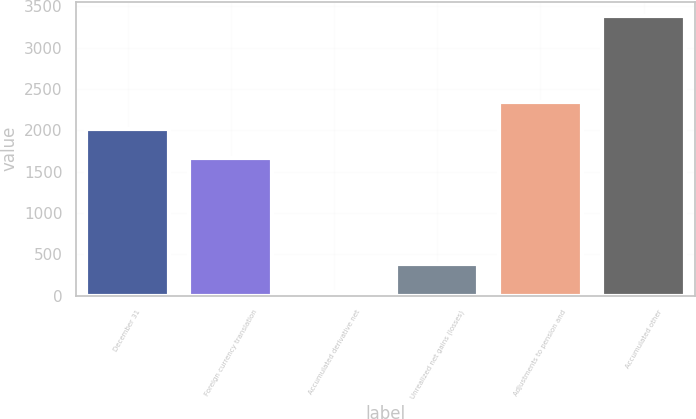Convert chart to OTSL. <chart><loc_0><loc_0><loc_500><loc_500><bar_chart><fcel>December 31<fcel>Foreign currency translation<fcel>Accumulated derivative net<fcel>Unrealized net gains (losses)<fcel>Adjustments to pension and<fcel>Accumulated other<nl><fcel>2012<fcel>1665<fcel>46<fcel>379.9<fcel>2345.9<fcel>3385<nl></chart> 